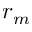<formula> <loc_0><loc_0><loc_500><loc_500>r _ { m }</formula> 